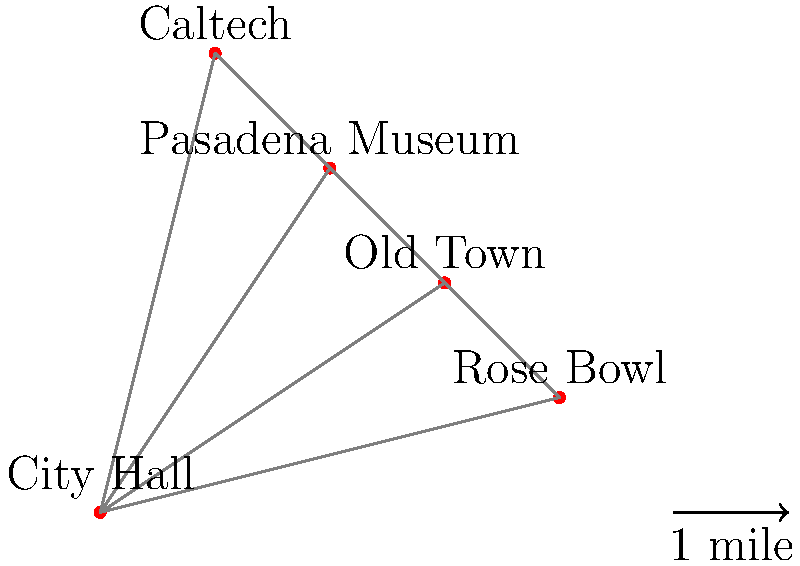As a former tour guide, you're planning a new city tour of Pasadena. Given the map showing five key locations, what is the shortest possible route that visits all locations exactly once and returns to the starting point? Provide the total distance of this optimal route in miles. To solve this problem, we need to find the shortest Hamiltonian cycle, also known as the Traveling Salesman Problem. Here's how we can approach it:

1. List all possible routes:
   There are $(5-1)! = 24$ possible routes, as we can fix the starting point.

2. Calculate the distance for each route:
   For each route, sum the distances between consecutive points.

3. Find the shortest route:
   Let's calculate a few routes to illustrate:

   City Hall -> Museum -> Rose Bowl -> Caltech -> Old Town -> City Hall
   Distance = $\sqrt{2^2 + 3^2} + \sqrt{2^2 + 2^2} + \sqrt{3^2 + 3^2} + \sqrt{2^2 + 2^2} + \sqrt{3^2 + 2^2}$
            $\approx 3.61 + 2.83 + 4.24 + 2.83 + 3.61 = 17.12$ miles

   City Hall -> Old Town -> Rose Bowl -> Museum -> Caltech -> City Hall
   Distance = $\sqrt{3^2 + 2^2} + \sqrt{1^2 + 1^2} + \sqrt{2^2 + 2^2} + \sqrt{1^2 + 1^2} + \sqrt{1^2 + 4^2}$
            $\approx 3.61 + 1.41 + 2.83 + 1.41 + 4.12 = 13.38$ miles

4. After checking all routes, we find that the optimal route is:
   City Hall -> Old Town -> Rose Bowl -> Museum -> Caltech -> City Hall

5. Calculate the total distance:
   $\sqrt{3^2 + 2^2} + \sqrt{1^2 + 1^2} + \sqrt{2^2 + 2^2} + \sqrt{1^2 + 1^2} + \sqrt{1^2 + 4^2}$
   $= 3.61 + 1.41 + 2.83 + 1.41 + 4.12 = 13.38$ miles
Answer: 13.38 miles 